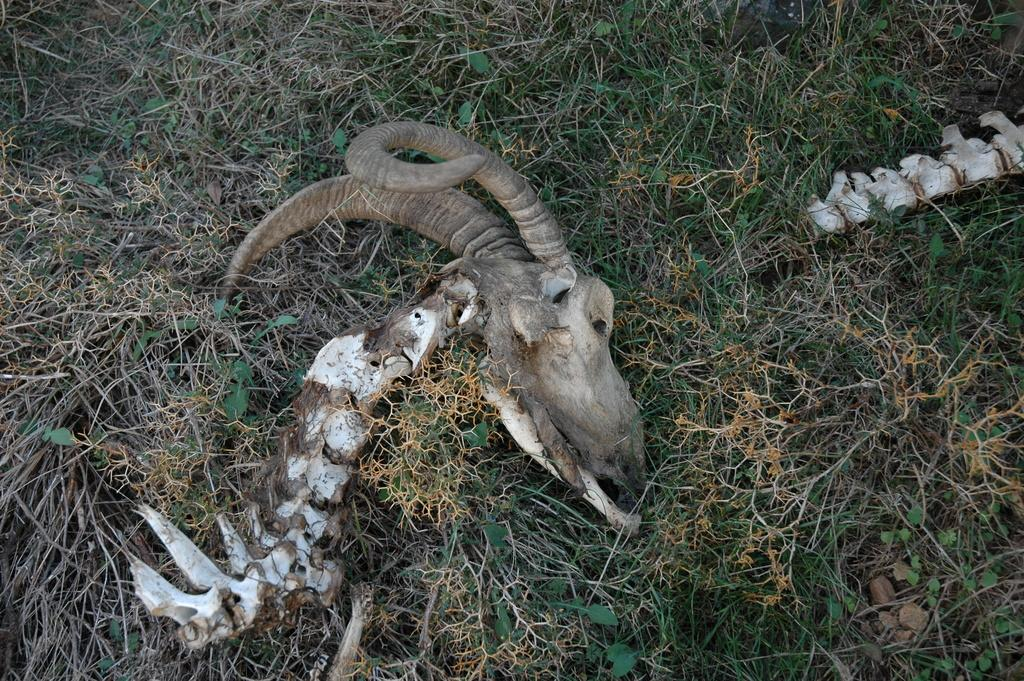What is the main subject of the image? The main subject of the image is an animal head. Where is the animal head located? The animal head is on the grass. Is there a need for an umbrella in the image? There is no mention of rain or the need for an umbrella in the image. The image only features an animal head on the grass. 